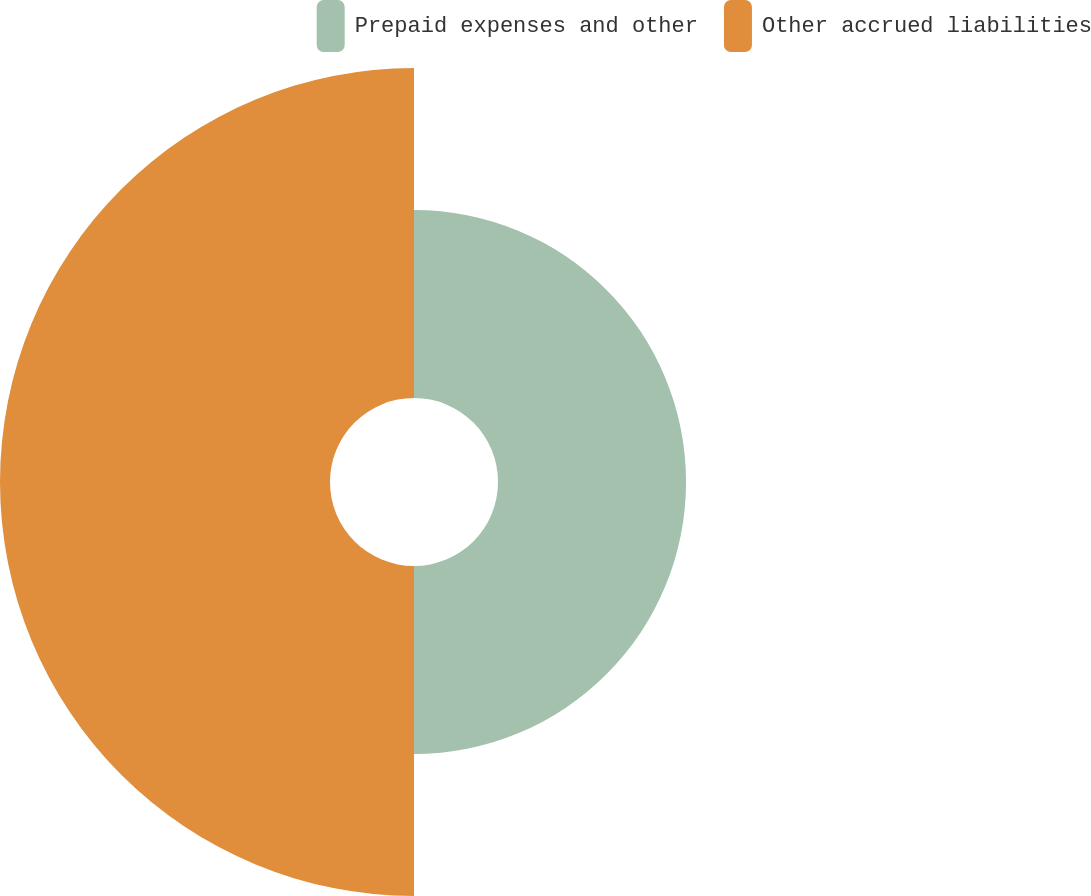Convert chart to OTSL. <chart><loc_0><loc_0><loc_500><loc_500><pie_chart><fcel>Prepaid expenses and other<fcel>Other accrued liabilities<nl><fcel>36.3%<fcel>63.7%<nl></chart> 